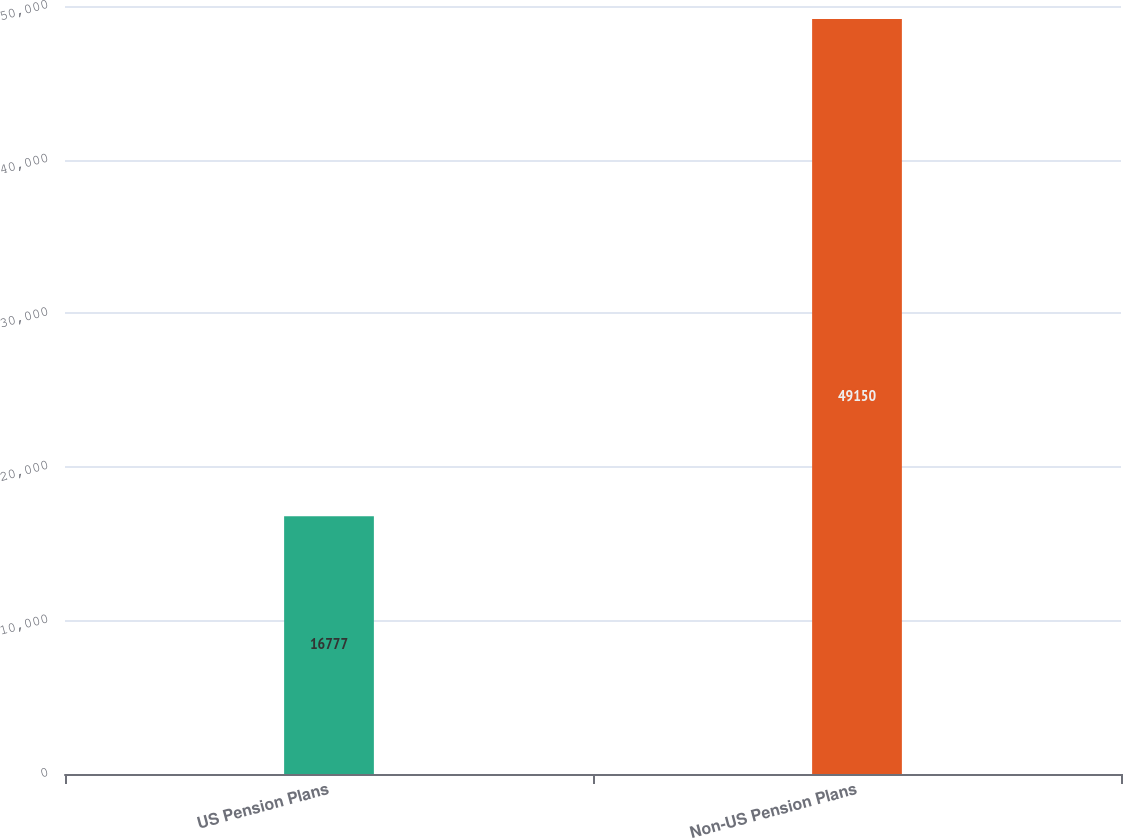<chart> <loc_0><loc_0><loc_500><loc_500><bar_chart><fcel>US Pension Plans<fcel>Non-US Pension Plans<nl><fcel>16777<fcel>49150<nl></chart> 